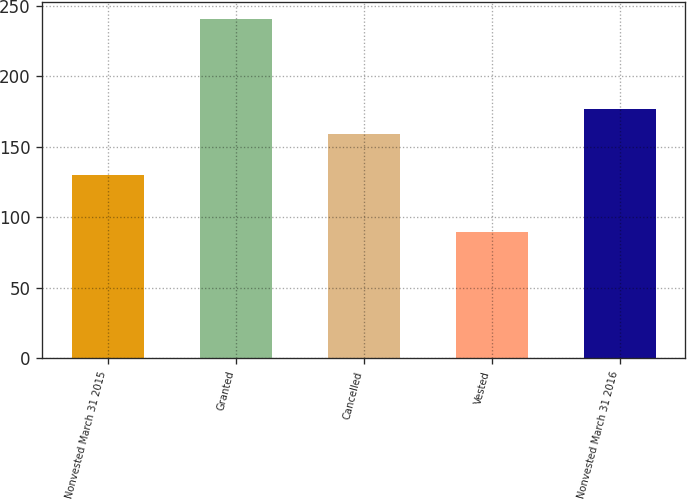<chart> <loc_0><loc_0><loc_500><loc_500><bar_chart><fcel>Nonvested March 31 2015<fcel>Granted<fcel>Cancelled<fcel>Vested<fcel>Nonvested March 31 2016<nl><fcel>129.57<fcel>240.35<fcel>159.17<fcel>89.44<fcel>176.59<nl></chart> 